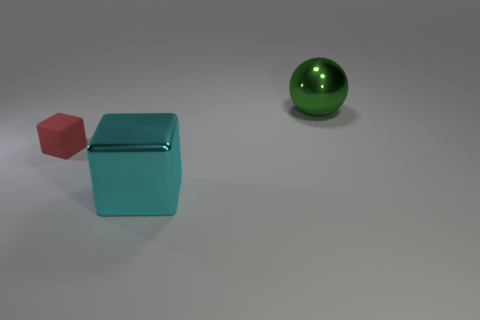There is another thing that is the same shape as the large cyan object; what is its size?
Give a very brief answer. Small. What is the shape of the large object that is in front of the small red rubber cube?
Provide a short and direct response. Cube. Is the thing behind the tiny red object made of the same material as the thing on the left side of the large cyan block?
Make the answer very short. No. There is a large green metallic thing; what shape is it?
Offer a terse response. Sphere. Are there an equal number of big cyan shiny objects on the right side of the large green sphere and small red blocks?
Your answer should be compact. No. Are there any large brown things that have the same material as the big cyan cube?
Give a very brief answer. No. There is a big metal thing in front of the green object; is it the same shape as the big shiny object that is behind the tiny red rubber thing?
Your answer should be very brief. No. Are there any large gray matte blocks?
Make the answer very short. No. What color is the ball that is the same size as the metallic block?
Provide a short and direct response. Green. What number of large cyan things have the same shape as the large green metal thing?
Offer a terse response. 0. 